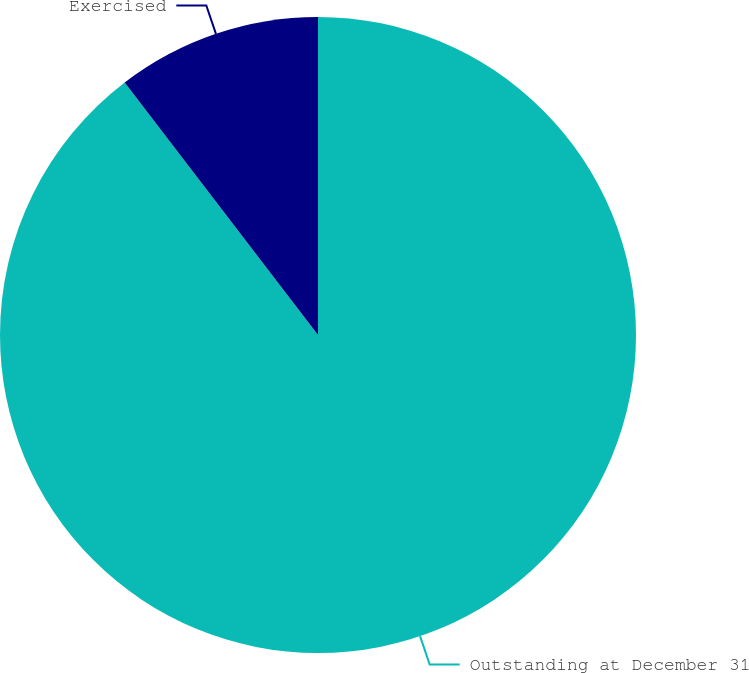<chart> <loc_0><loc_0><loc_500><loc_500><pie_chart><fcel>Outstanding at December 31<fcel>Exercised<nl><fcel>89.6%<fcel>10.4%<nl></chart> 